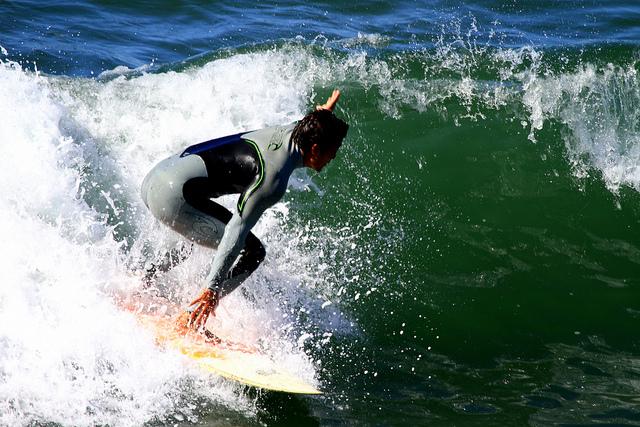What sport is this?
Short answer required. Surfing. Is this person wearing a wetsuit?
Short answer required. Yes. What color is the water?
Give a very brief answer. Green. 